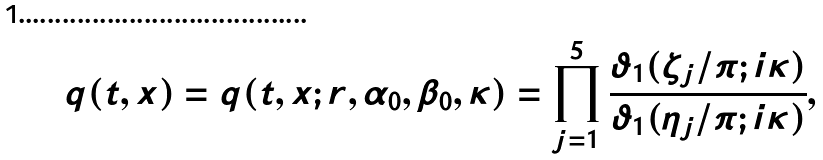Convert formula to latex. <formula><loc_0><loc_0><loc_500><loc_500>q ( t , x ) = q ( t , x ; r , \alpha _ { 0 } , \beta _ { 0 } , \kappa ) = \prod _ { j = 1 } ^ { 5 } \frac { \vartheta _ { 1 } ( \zeta _ { j } / \pi ; i \kappa ) } { \vartheta _ { 1 } ( \eta _ { j } / \pi ; i \kappa ) } ,</formula> 